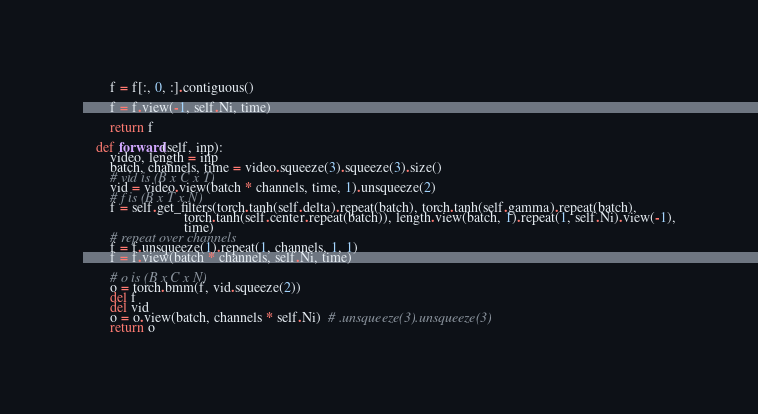<code> <loc_0><loc_0><loc_500><loc_500><_Python_>        f = f[:, 0, :].contiguous()

        f = f.view(-1, self.Ni, time)

        return f

    def forward(self, inp):
        video, length = inp
        batch, channels, time = video.squeeze(3).squeeze(3).size()
        # vid is (B x C x T)
        vid = video.view(batch * channels, time, 1).unsqueeze(2)
        # f is (B x T x N)
        f = self.get_filters(torch.tanh(self.delta).repeat(batch), torch.tanh(self.gamma).repeat(batch),
                             torch.tanh(self.center.repeat(batch)), length.view(batch, 1).repeat(1, self.Ni).view(-1),
                             time)
        # repeat over channels
        f = f.unsqueeze(1).repeat(1, channels, 1, 1)
        f = f.view(batch * channels, self.Ni, time)

        # o is (B x C x N)
        o = torch.bmm(f, vid.squeeze(2))
        del f
        del vid
        o = o.view(batch, channels * self.Ni)  # .unsqueeze(3).unsqueeze(3)
        return o


</code> 